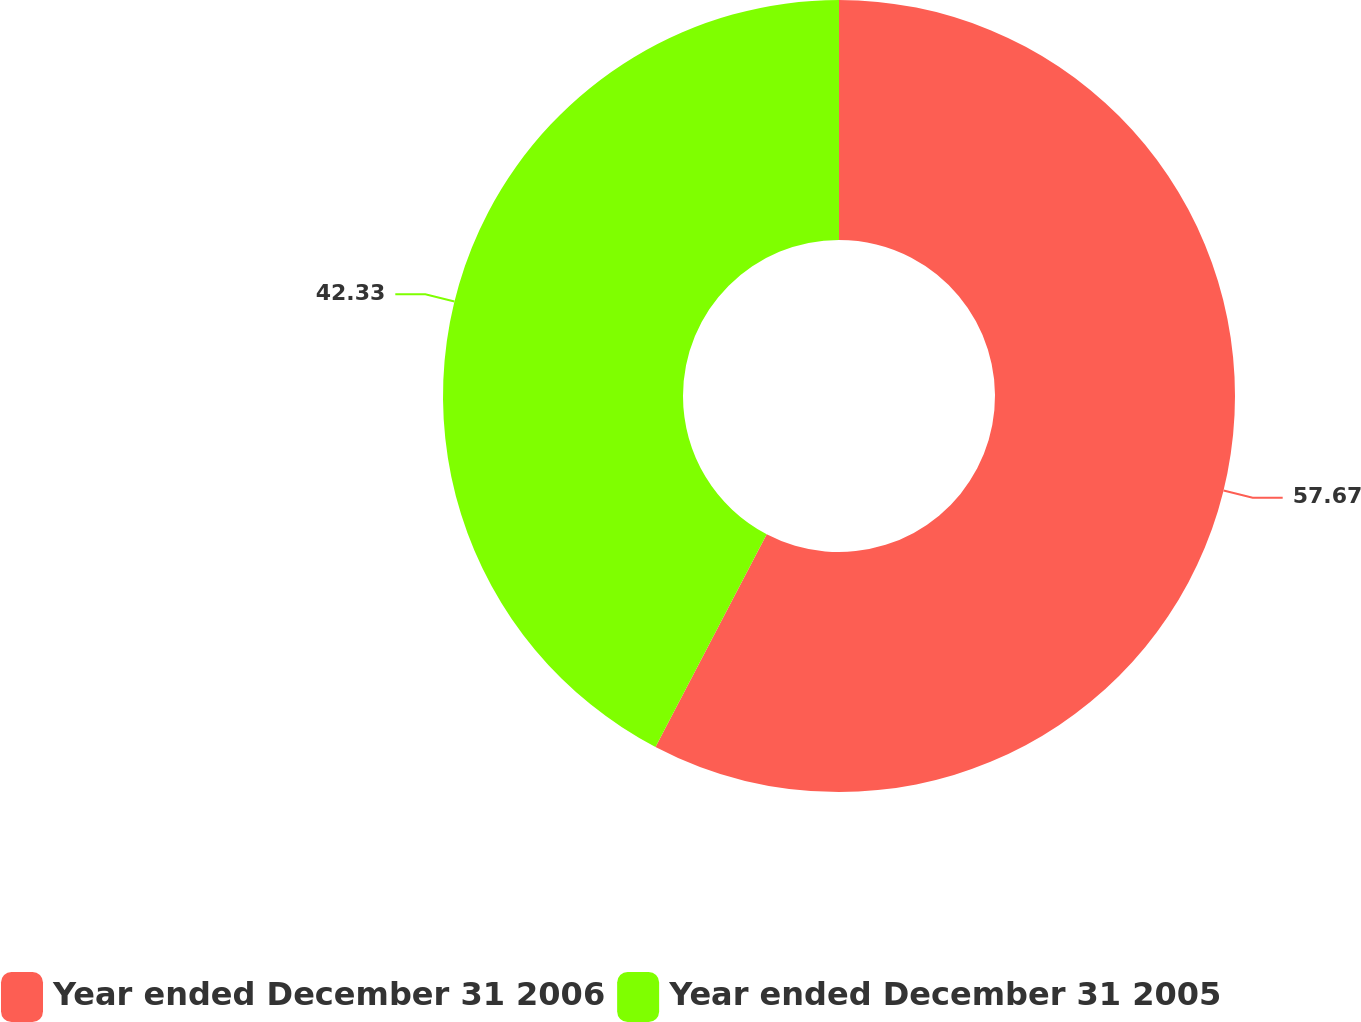Convert chart to OTSL. <chart><loc_0><loc_0><loc_500><loc_500><pie_chart><fcel>Year ended December 31 2006<fcel>Year ended December 31 2005<nl><fcel>57.67%<fcel>42.33%<nl></chart> 